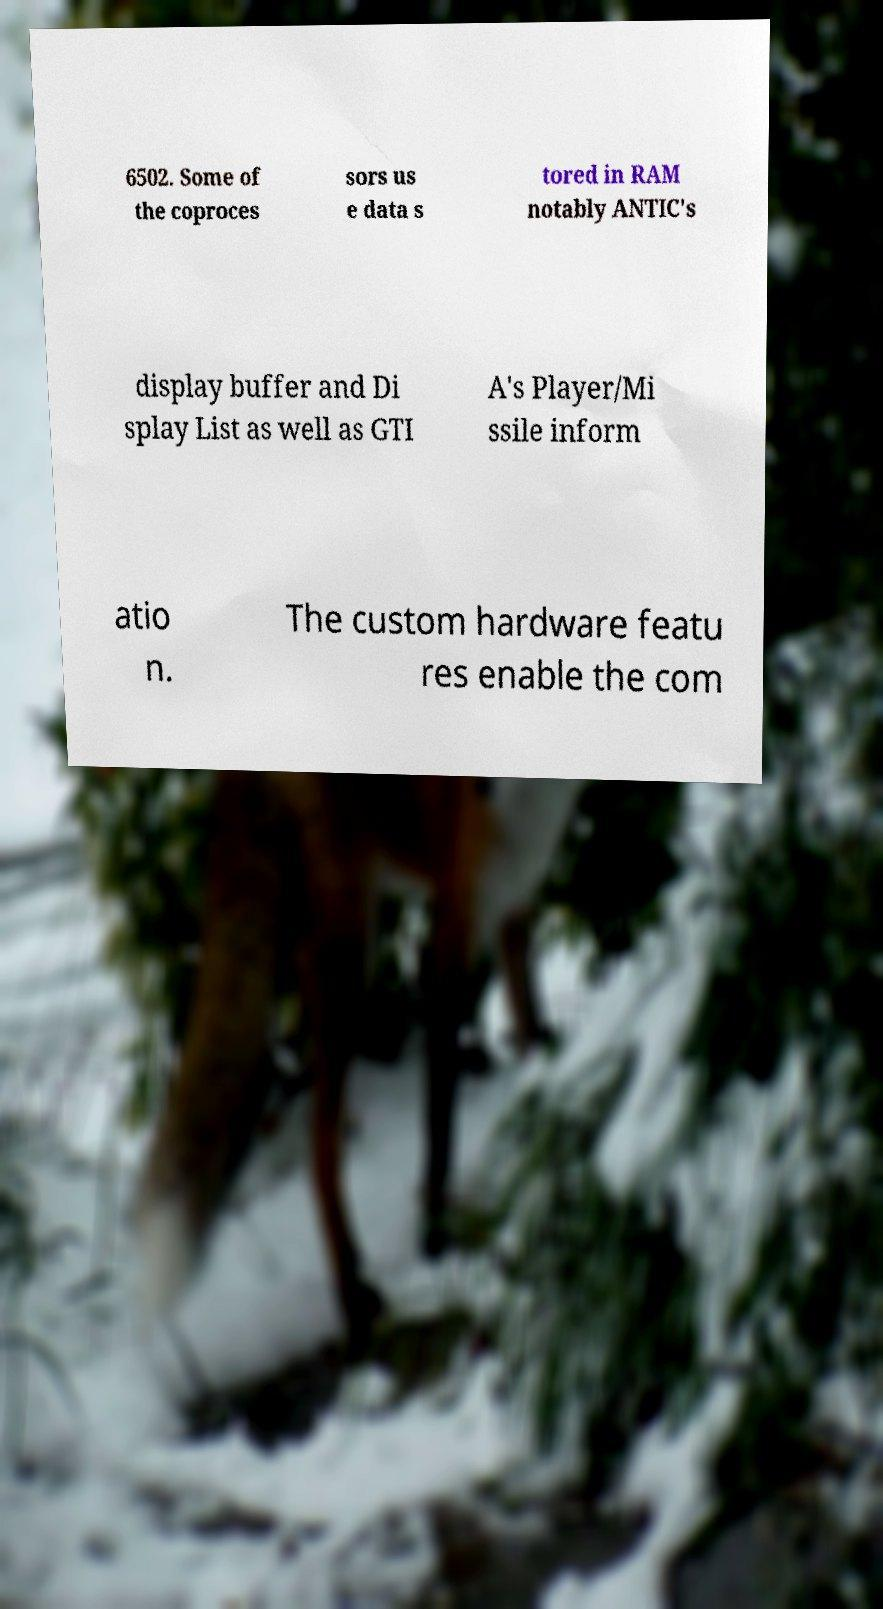Could you assist in decoding the text presented in this image and type it out clearly? 6502. Some of the coproces sors us e data s tored in RAM notably ANTIC's display buffer and Di splay List as well as GTI A's Player/Mi ssile inform atio n. The custom hardware featu res enable the com 